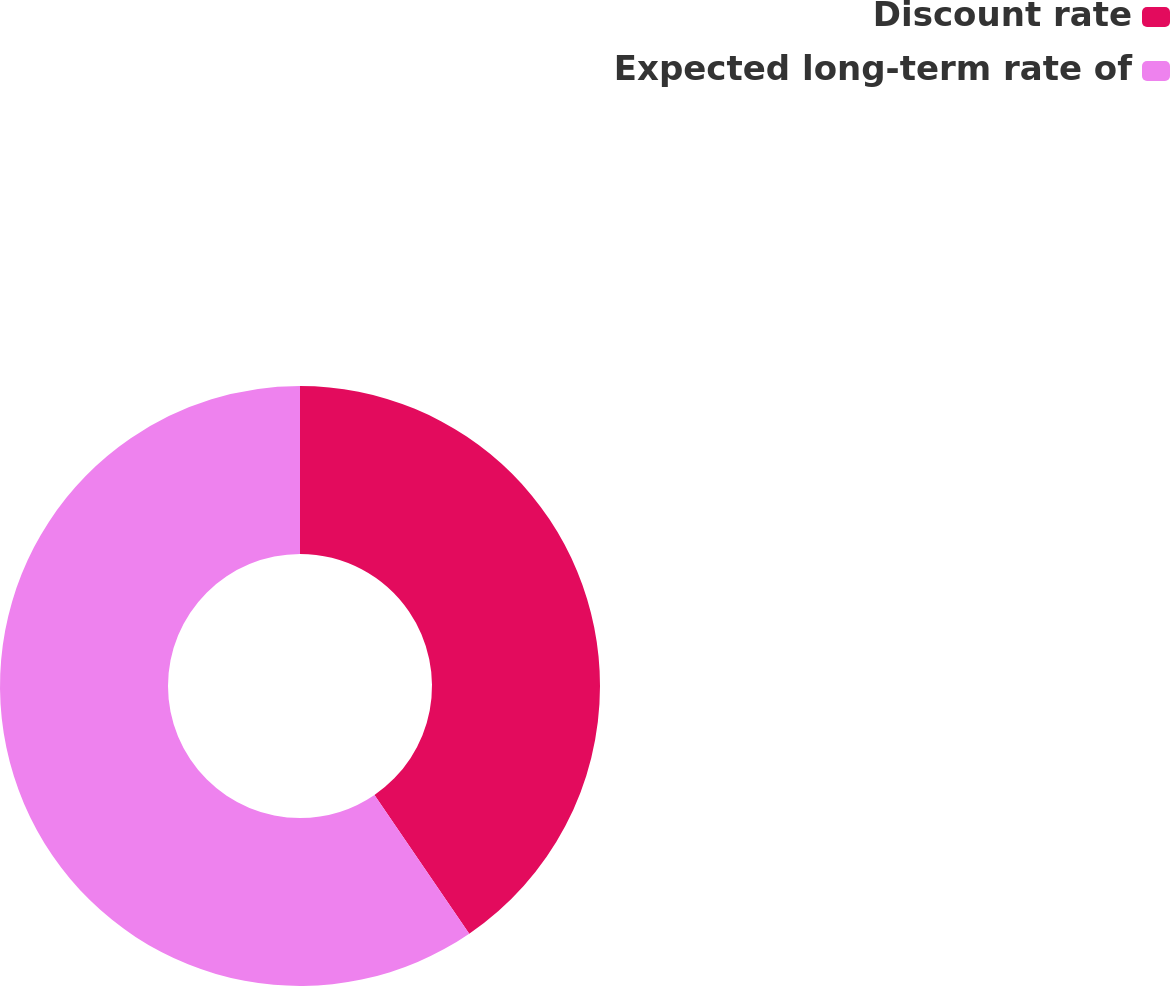Convert chart to OTSL. <chart><loc_0><loc_0><loc_500><loc_500><pie_chart><fcel>Discount rate<fcel>Expected long-term rate of<nl><fcel>40.46%<fcel>59.54%<nl></chart> 